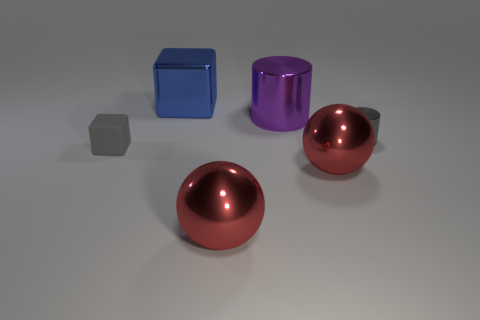Add 1 spheres. How many objects exist? 7 Subtract all cubes. How many objects are left? 4 Add 3 large red metallic spheres. How many large red metallic spheres are left? 5 Add 4 big shiny cylinders. How many big shiny cylinders exist? 5 Subtract 0 purple spheres. How many objects are left? 6 Subtract all red objects. Subtract all tiny gray rubber objects. How many objects are left? 3 